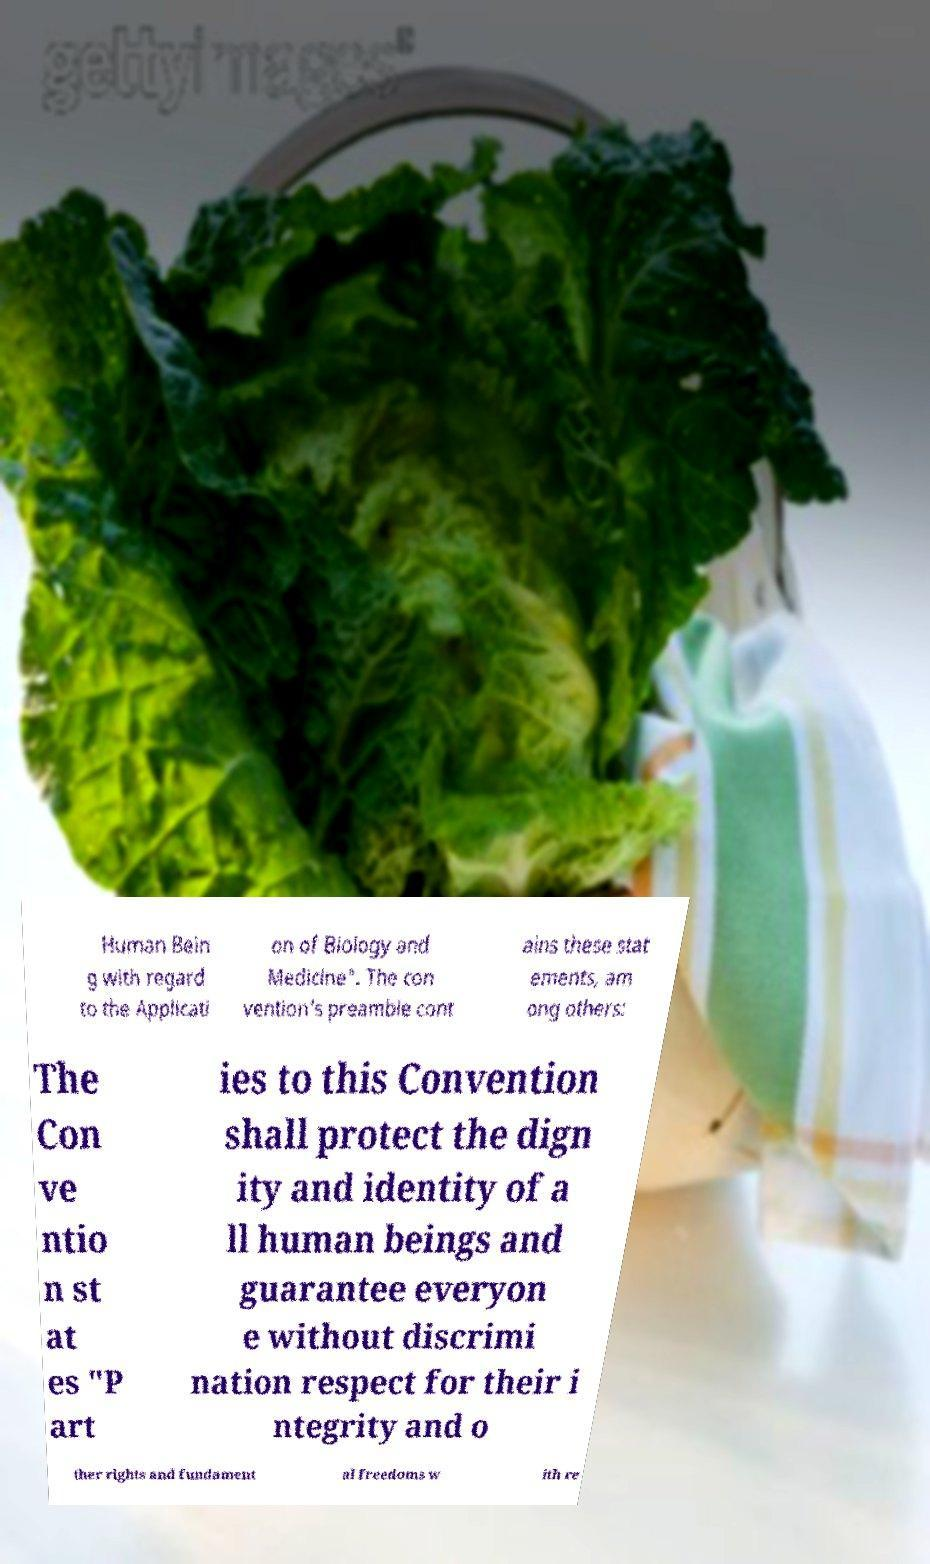What messages or text are displayed in this image? I need them in a readable, typed format. Human Bein g with regard to the Applicati on of Biology and Medicine". The con vention's preamble cont ains these stat ements, am ong others: The Con ve ntio n st at es "P art ies to this Convention shall protect the dign ity and identity of a ll human beings and guarantee everyon e without discrimi nation respect for their i ntegrity and o ther rights and fundament al freedoms w ith re 